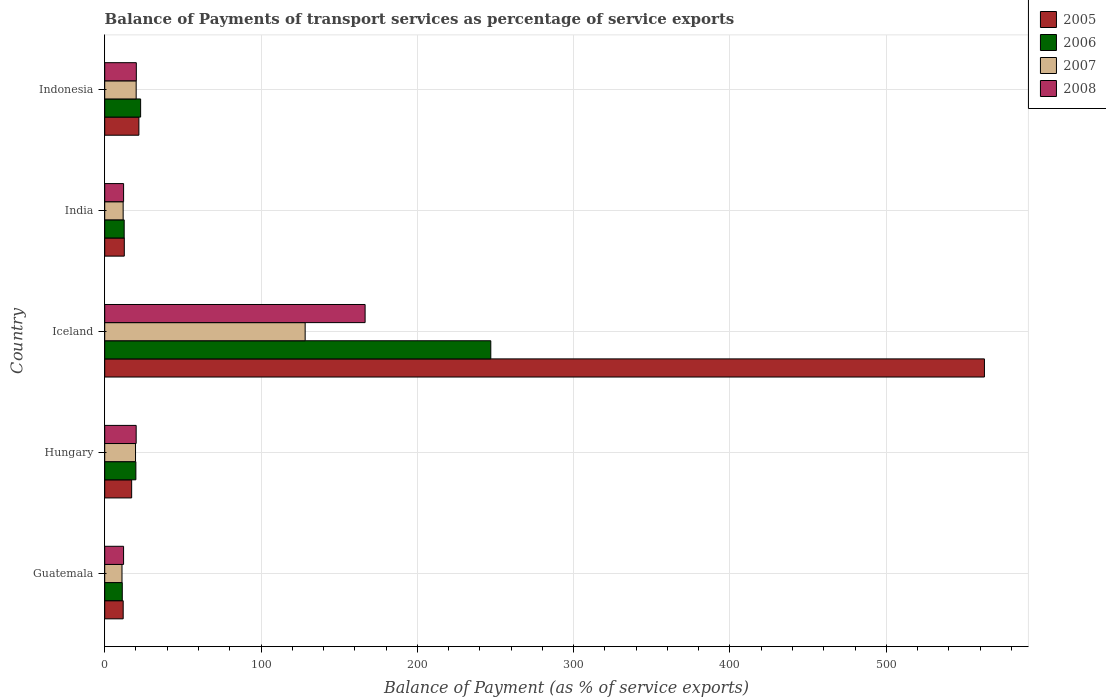How many groups of bars are there?
Give a very brief answer. 5. Are the number of bars per tick equal to the number of legend labels?
Provide a succinct answer. Yes. Are the number of bars on each tick of the Y-axis equal?
Your answer should be very brief. Yes. How many bars are there on the 4th tick from the bottom?
Your answer should be compact. 4. What is the label of the 5th group of bars from the top?
Make the answer very short. Guatemala. What is the balance of payments of transport services in 2008 in Indonesia?
Give a very brief answer. 20.22. Across all countries, what is the maximum balance of payments of transport services in 2008?
Provide a succinct answer. 166.58. Across all countries, what is the minimum balance of payments of transport services in 2006?
Your response must be concise. 11.24. In which country was the balance of payments of transport services in 2006 maximum?
Offer a terse response. Iceland. In which country was the balance of payments of transport services in 2005 minimum?
Make the answer very short. Guatemala. What is the total balance of payments of transport services in 2006 in the graph?
Your answer should be very brief. 313.6. What is the difference between the balance of payments of transport services in 2006 in India and that in Indonesia?
Give a very brief answer. -10.52. What is the difference between the balance of payments of transport services in 2006 in India and the balance of payments of transport services in 2008 in Guatemala?
Provide a short and direct response. 0.4. What is the average balance of payments of transport services in 2007 per country?
Provide a succinct answer. 38.18. What is the difference between the balance of payments of transport services in 2006 and balance of payments of transport services in 2007 in Hungary?
Keep it short and to the point. 0.22. In how many countries, is the balance of payments of transport services in 2005 greater than 300 %?
Offer a terse response. 1. What is the ratio of the balance of payments of transport services in 2006 in Guatemala to that in Indonesia?
Your response must be concise. 0.49. What is the difference between the highest and the second highest balance of payments of transport services in 2005?
Your response must be concise. 540.94. What is the difference between the highest and the lowest balance of payments of transport services in 2007?
Give a very brief answer. 117.17. In how many countries, is the balance of payments of transport services in 2007 greater than the average balance of payments of transport services in 2007 taken over all countries?
Your answer should be compact. 1. What does the 2nd bar from the bottom in Guatemala represents?
Your answer should be compact. 2006. How many bars are there?
Provide a short and direct response. 20. How many countries are there in the graph?
Offer a terse response. 5. Are the values on the major ticks of X-axis written in scientific E-notation?
Keep it short and to the point. No. Where does the legend appear in the graph?
Provide a short and direct response. Top right. How many legend labels are there?
Your answer should be compact. 4. How are the legend labels stacked?
Provide a short and direct response. Vertical. What is the title of the graph?
Offer a terse response. Balance of Payments of transport services as percentage of service exports. Does "2002" appear as one of the legend labels in the graph?
Your answer should be compact. No. What is the label or title of the X-axis?
Keep it short and to the point. Balance of Payment (as % of service exports). What is the Balance of Payment (as % of service exports) of 2005 in Guatemala?
Provide a succinct answer. 11.81. What is the Balance of Payment (as % of service exports) in 2006 in Guatemala?
Provide a short and direct response. 11.24. What is the Balance of Payment (as % of service exports) in 2007 in Guatemala?
Your answer should be very brief. 11.06. What is the Balance of Payment (as % of service exports) of 2008 in Guatemala?
Provide a short and direct response. 12.06. What is the Balance of Payment (as % of service exports) in 2005 in Hungary?
Keep it short and to the point. 17.23. What is the Balance of Payment (as % of service exports) in 2006 in Hungary?
Your answer should be very brief. 19.93. What is the Balance of Payment (as % of service exports) in 2007 in Hungary?
Ensure brevity in your answer.  19.71. What is the Balance of Payment (as % of service exports) in 2008 in Hungary?
Your answer should be very brief. 20.12. What is the Balance of Payment (as % of service exports) of 2005 in Iceland?
Your answer should be very brief. 562.81. What is the Balance of Payment (as % of service exports) of 2006 in Iceland?
Ensure brevity in your answer.  247. What is the Balance of Payment (as % of service exports) in 2007 in Iceland?
Provide a succinct answer. 128.23. What is the Balance of Payment (as % of service exports) in 2008 in Iceland?
Provide a short and direct response. 166.58. What is the Balance of Payment (as % of service exports) in 2005 in India?
Your answer should be compact. 12.53. What is the Balance of Payment (as % of service exports) of 2006 in India?
Your answer should be very brief. 12.46. What is the Balance of Payment (as % of service exports) in 2007 in India?
Give a very brief answer. 11.8. What is the Balance of Payment (as % of service exports) in 2008 in India?
Give a very brief answer. 12.07. What is the Balance of Payment (as % of service exports) in 2005 in Indonesia?
Give a very brief answer. 21.87. What is the Balance of Payment (as % of service exports) of 2006 in Indonesia?
Keep it short and to the point. 22.98. What is the Balance of Payment (as % of service exports) in 2007 in Indonesia?
Offer a terse response. 20.12. What is the Balance of Payment (as % of service exports) in 2008 in Indonesia?
Offer a terse response. 20.22. Across all countries, what is the maximum Balance of Payment (as % of service exports) of 2005?
Give a very brief answer. 562.81. Across all countries, what is the maximum Balance of Payment (as % of service exports) of 2006?
Provide a succinct answer. 247. Across all countries, what is the maximum Balance of Payment (as % of service exports) in 2007?
Your answer should be compact. 128.23. Across all countries, what is the maximum Balance of Payment (as % of service exports) of 2008?
Your answer should be very brief. 166.58. Across all countries, what is the minimum Balance of Payment (as % of service exports) of 2005?
Make the answer very short. 11.81. Across all countries, what is the minimum Balance of Payment (as % of service exports) in 2006?
Your response must be concise. 11.24. Across all countries, what is the minimum Balance of Payment (as % of service exports) in 2007?
Your answer should be very brief. 11.06. Across all countries, what is the minimum Balance of Payment (as % of service exports) of 2008?
Your answer should be very brief. 12.06. What is the total Balance of Payment (as % of service exports) in 2005 in the graph?
Keep it short and to the point. 626.25. What is the total Balance of Payment (as % of service exports) of 2006 in the graph?
Your response must be concise. 313.6. What is the total Balance of Payment (as % of service exports) of 2007 in the graph?
Ensure brevity in your answer.  190.92. What is the total Balance of Payment (as % of service exports) in 2008 in the graph?
Ensure brevity in your answer.  231.06. What is the difference between the Balance of Payment (as % of service exports) in 2005 in Guatemala and that in Hungary?
Provide a succinct answer. -5.42. What is the difference between the Balance of Payment (as % of service exports) of 2006 in Guatemala and that in Hungary?
Your answer should be very brief. -8.7. What is the difference between the Balance of Payment (as % of service exports) in 2007 in Guatemala and that in Hungary?
Ensure brevity in your answer.  -8.66. What is the difference between the Balance of Payment (as % of service exports) in 2008 in Guatemala and that in Hungary?
Your response must be concise. -8.06. What is the difference between the Balance of Payment (as % of service exports) in 2005 in Guatemala and that in Iceland?
Make the answer very short. -550.99. What is the difference between the Balance of Payment (as % of service exports) of 2006 in Guatemala and that in Iceland?
Provide a succinct answer. -235.76. What is the difference between the Balance of Payment (as % of service exports) of 2007 in Guatemala and that in Iceland?
Provide a succinct answer. -117.17. What is the difference between the Balance of Payment (as % of service exports) in 2008 in Guatemala and that in Iceland?
Your answer should be compact. -154.52. What is the difference between the Balance of Payment (as % of service exports) of 2005 in Guatemala and that in India?
Your answer should be compact. -0.71. What is the difference between the Balance of Payment (as % of service exports) in 2006 in Guatemala and that in India?
Your answer should be very brief. -1.22. What is the difference between the Balance of Payment (as % of service exports) in 2007 in Guatemala and that in India?
Your answer should be compact. -0.74. What is the difference between the Balance of Payment (as % of service exports) in 2008 in Guatemala and that in India?
Offer a very short reply. -0.01. What is the difference between the Balance of Payment (as % of service exports) in 2005 in Guatemala and that in Indonesia?
Keep it short and to the point. -10.05. What is the difference between the Balance of Payment (as % of service exports) of 2006 in Guatemala and that in Indonesia?
Ensure brevity in your answer.  -11.74. What is the difference between the Balance of Payment (as % of service exports) of 2007 in Guatemala and that in Indonesia?
Provide a short and direct response. -9.07. What is the difference between the Balance of Payment (as % of service exports) of 2008 in Guatemala and that in Indonesia?
Offer a terse response. -8.16. What is the difference between the Balance of Payment (as % of service exports) of 2005 in Hungary and that in Iceland?
Provide a short and direct response. -545.58. What is the difference between the Balance of Payment (as % of service exports) of 2006 in Hungary and that in Iceland?
Your answer should be compact. -227.06. What is the difference between the Balance of Payment (as % of service exports) in 2007 in Hungary and that in Iceland?
Keep it short and to the point. -108.51. What is the difference between the Balance of Payment (as % of service exports) in 2008 in Hungary and that in Iceland?
Provide a succinct answer. -146.46. What is the difference between the Balance of Payment (as % of service exports) of 2005 in Hungary and that in India?
Offer a very short reply. 4.7. What is the difference between the Balance of Payment (as % of service exports) in 2006 in Hungary and that in India?
Provide a short and direct response. 7.47. What is the difference between the Balance of Payment (as % of service exports) of 2007 in Hungary and that in India?
Your answer should be compact. 7.92. What is the difference between the Balance of Payment (as % of service exports) in 2008 in Hungary and that in India?
Your answer should be compact. 8.05. What is the difference between the Balance of Payment (as % of service exports) in 2005 in Hungary and that in Indonesia?
Keep it short and to the point. -4.64. What is the difference between the Balance of Payment (as % of service exports) of 2006 in Hungary and that in Indonesia?
Provide a short and direct response. -3.04. What is the difference between the Balance of Payment (as % of service exports) in 2007 in Hungary and that in Indonesia?
Give a very brief answer. -0.41. What is the difference between the Balance of Payment (as % of service exports) in 2008 in Hungary and that in Indonesia?
Your answer should be compact. -0.1. What is the difference between the Balance of Payment (as % of service exports) in 2005 in Iceland and that in India?
Your answer should be very brief. 550.28. What is the difference between the Balance of Payment (as % of service exports) of 2006 in Iceland and that in India?
Give a very brief answer. 234.54. What is the difference between the Balance of Payment (as % of service exports) in 2007 in Iceland and that in India?
Keep it short and to the point. 116.43. What is the difference between the Balance of Payment (as % of service exports) in 2008 in Iceland and that in India?
Provide a short and direct response. 154.51. What is the difference between the Balance of Payment (as % of service exports) in 2005 in Iceland and that in Indonesia?
Ensure brevity in your answer.  540.94. What is the difference between the Balance of Payment (as % of service exports) in 2006 in Iceland and that in Indonesia?
Give a very brief answer. 224.02. What is the difference between the Balance of Payment (as % of service exports) in 2007 in Iceland and that in Indonesia?
Your answer should be very brief. 108.1. What is the difference between the Balance of Payment (as % of service exports) in 2008 in Iceland and that in Indonesia?
Provide a short and direct response. 146.36. What is the difference between the Balance of Payment (as % of service exports) in 2005 in India and that in Indonesia?
Your answer should be very brief. -9.34. What is the difference between the Balance of Payment (as % of service exports) in 2006 in India and that in Indonesia?
Provide a short and direct response. -10.52. What is the difference between the Balance of Payment (as % of service exports) of 2007 in India and that in Indonesia?
Offer a very short reply. -8.33. What is the difference between the Balance of Payment (as % of service exports) in 2008 in India and that in Indonesia?
Give a very brief answer. -8.15. What is the difference between the Balance of Payment (as % of service exports) in 2005 in Guatemala and the Balance of Payment (as % of service exports) in 2006 in Hungary?
Provide a short and direct response. -8.12. What is the difference between the Balance of Payment (as % of service exports) of 2005 in Guatemala and the Balance of Payment (as % of service exports) of 2007 in Hungary?
Provide a succinct answer. -7.9. What is the difference between the Balance of Payment (as % of service exports) of 2005 in Guatemala and the Balance of Payment (as % of service exports) of 2008 in Hungary?
Offer a terse response. -8.31. What is the difference between the Balance of Payment (as % of service exports) of 2006 in Guatemala and the Balance of Payment (as % of service exports) of 2007 in Hungary?
Give a very brief answer. -8.47. What is the difference between the Balance of Payment (as % of service exports) of 2006 in Guatemala and the Balance of Payment (as % of service exports) of 2008 in Hungary?
Provide a short and direct response. -8.88. What is the difference between the Balance of Payment (as % of service exports) of 2007 in Guatemala and the Balance of Payment (as % of service exports) of 2008 in Hungary?
Make the answer very short. -9.06. What is the difference between the Balance of Payment (as % of service exports) in 2005 in Guatemala and the Balance of Payment (as % of service exports) in 2006 in Iceland?
Your answer should be very brief. -235.18. What is the difference between the Balance of Payment (as % of service exports) of 2005 in Guatemala and the Balance of Payment (as % of service exports) of 2007 in Iceland?
Ensure brevity in your answer.  -116.41. What is the difference between the Balance of Payment (as % of service exports) in 2005 in Guatemala and the Balance of Payment (as % of service exports) in 2008 in Iceland?
Make the answer very short. -154.77. What is the difference between the Balance of Payment (as % of service exports) of 2006 in Guatemala and the Balance of Payment (as % of service exports) of 2007 in Iceland?
Offer a very short reply. -116.99. What is the difference between the Balance of Payment (as % of service exports) of 2006 in Guatemala and the Balance of Payment (as % of service exports) of 2008 in Iceland?
Give a very brief answer. -155.34. What is the difference between the Balance of Payment (as % of service exports) of 2007 in Guatemala and the Balance of Payment (as % of service exports) of 2008 in Iceland?
Give a very brief answer. -155.53. What is the difference between the Balance of Payment (as % of service exports) of 2005 in Guatemala and the Balance of Payment (as % of service exports) of 2006 in India?
Offer a terse response. -0.65. What is the difference between the Balance of Payment (as % of service exports) in 2005 in Guatemala and the Balance of Payment (as % of service exports) in 2007 in India?
Your answer should be very brief. 0.02. What is the difference between the Balance of Payment (as % of service exports) of 2005 in Guatemala and the Balance of Payment (as % of service exports) of 2008 in India?
Provide a succinct answer. -0.26. What is the difference between the Balance of Payment (as % of service exports) of 2006 in Guatemala and the Balance of Payment (as % of service exports) of 2007 in India?
Provide a short and direct response. -0.56. What is the difference between the Balance of Payment (as % of service exports) in 2006 in Guatemala and the Balance of Payment (as % of service exports) in 2008 in India?
Offer a very short reply. -0.83. What is the difference between the Balance of Payment (as % of service exports) of 2007 in Guatemala and the Balance of Payment (as % of service exports) of 2008 in India?
Provide a succinct answer. -1.02. What is the difference between the Balance of Payment (as % of service exports) in 2005 in Guatemala and the Balance of Payment (as % of service exports) in 2006 in Indonesia?
Keep it short and to the point. -11.16. What is the difference between the Balance of Payment (as % of service exports) of 2005 in Guatemala and the Balance of Payment (as % of service exports) of 2007 in Indonesia?
Give a very brief answer. -8.31. What is the difference between the Balance of Payment (as % of service exports) of 2005 in Guatemala and the Balance of Payment (as % of service exports) of 2008 in Indonesia?
Provide a short and direct response. -8.41. What is the difference between the Balance of Payment (as % of service exports) of 2006 in Guatemala and the Balance of Payment (as % of service exports) of 2007 in Indonesia?
Offer a terse response. -8.89. What is the difference between the Balance of Payment (as % of service exports) of 2006 in Guatemala and the Balance of Payment (as % of service exports) of 2008 in Indonesia?
Your answer should be very brief. -8.99. What is the difference between the Balance of Payment (as % of service exports) of 2007 in Guatemala and the Balance of Payment (as % of service exports) of 2008 in Indonesia?
Provide a succinct answer. -9.17. What is the difference between the Balance of Payment (as % of service exports) of 2005 in Hungary and the Balance of Payment (as % of service exports) of 2006 in Iceland?
Give a very brief answer. -229.77. What is the difference between the Balance of Payment (as % of service exports) in 2005 in Hungary and the Balance of Payment (as % of service exports) in 2007 in Iceland?
Your answer should be compact. -111. What is the difference between the Balance of Payment (as % of service exports) of 2005 in Hungary and the Balance of Payment (as % of service exports) of 2008 in Iceland?
Provide a succinct answer. -149.35. What is the difference between the Balance of Payment (as % of service exports) of 2006 in Hungary and the Balance of Payment (as % of service exports) of 2007 in Iceland?
Offer a very short reply. -108.29. What is the difference between the Balance of Payment (as % of service exports) in 2006 in Hungary and the Balance of Payment (as % of service exports) in 2008 in Iceland?
Make the answer very short. -146.65. What is the difference between the Balance of Payment (as % of service exports) of 2007 in Hungary and the Balance of Payment (as % of service exports) of 2008 in Iceland?
Keep it short and to the point. -146.87. What is the difference between the Balance of Payment (as % of service exports) of 2005 in Hungary and the Balance of Payment (as % of service exports) of 2006 in India?
Ensure brevity in your answer.  4.77. What is the difference between the Balance of Payment (as % of service exports) in 2005 in Hungary and the Balance of Payment (as % of service exports) in 2007 in India?
Provide a short and direct response. 5.43. What is the difference between the Balance of Payment (as % of service exports) in 2005 in Hungary and the Balance of Payment (as % of service exports) in 2008 in India?
Your response must be concise. 5.16. What is the difference between the Balance of Payment (as % of service exports) in 2006 in Hungary and the Balance of Payment (as % of service exports) in 2007 in India?
Offer a very short reply. 8.14. What is the difference between the Balance of Payment (as % of service exports) of 2006 in Hungary and the Balance of Payment (as % of service exports) of 2008 in India?
Make the answer very short. 7.86. What is the difference between the Balance of Payment (as % of service exports) in 2007 in Hungary and the Balance of Payment (as % of service exports) in 2008 in India?
Offer a terse response. 7.64. What is the difference between the Balance of Payment (as % of service exports) of 2005 in Hungary and the Balance of Payment (as % of service exports) of 2006 in Indonesia?
Your response must be concise. -5.75. What is the difference between the Balance of Payment (as % of service exports) of 2005 in Hungary and the Balance of Payment (as % of service exports) of 2007 in Indonesia?
Provide a succinct answer. -2.89. What is the difference between the Balance of Payment (as % of service exports) of 2005 in Hungary and the Balance of Payment (as % of service exports) of 2008 in Indonesia?
Your answer should be compact. -2.99. What is the difference between the Balance of Payment (as % of service exports) in 2006 in Hungary and the Balance of Payment (as % of service exports) in 2007 in Indonesia?
Offer a terse response. -0.19. What is the difference between the Balance of Payment (as % of service exports) in 2006 in Hungary and the Balance of Payment (as % of service exports) in 2008 in Indonesia?
Your response must be concise. -0.29. What is the difference between the Balance of Payment (as % of service exports) of 2007 in Hungary and the Balance of Payment (as % of service exports) of 2008 in Indonesia?
Make the answer very short. -0.51. What is the difference between the Balance of Payment (as % of service exports) in 2005 in Iceland and the Balance of Payment (as % of service exports) in 2006 in India?
Your response must be concise. 550.35. What is the difference between the Balance of Payment (as % of service exports) in 2005 in Iceland and the Balance of Payment (as % of service exports) in 2007 in India?
Your response must be concise. 551.01. What is the difference between the Balance of Payment (as % of service exports) of 2005 in Iceland and the Balance of Payment (as % of service exports) of 2008 in India?
Offer a terse response. 550.73. What is the difference between the Balance of Payment (as % of service exports) in 2006 in Iceland and the Balance of Payment (as % of service exports) in 2007 in India?
Make the answer very short. 235.2. What is the difference between the Balance of Payment (as % of service exports) in 2006 in Iceland and the Balance of Payment (as % of service exports) in 2008 in India?
Offer a very short reply. 234.92. What is the difference between the Balance of Payment (as % of service exports) in 2007 in Iceland and the Balance of Payment (as % of service exports) in 2008 in India?
Your answer should be compact. 116.15. What is the difference between the Balance of Payment (as % of service exports) of 2005 in Iceland and the Balance of Payment (as % of service exports) of 2006 in Indonesia?
Offer a very short reply. 539.83. What is the difference between the Balance of Payment (as % of service exports) of 2005 in Iceland and the Balance of Payment (as % of service exports) of 2007 in Indonesia?
Provide a succinct answer. 542.68. What is the difference between the Balance of Payment (as % of service exports) of 2005 in Iceland and the Balance of Payment (as % of service exports) of 2008 in Indonesia?
Your answer should be compact. 542.58. What is the difference between the Balance of Payment (as % of service exports) of 2006 in Iceland and the Balance of Payment (as % of service exports) of 2007 in Indonesia?
Make the answer very short. 226.87. What is the difference between the Balance of Payment (as % of service exports) in 2006 in Iceland and the Balance of Payment (as % of service exports) in 2008 in Indonesia?
Your answer should be compact. 226.77. What is the difference between the Balance of Payment (as % of service exports) of 2007 in Iceland and the Balance of Payment (as % of service exports) of 2008 in Indonesia?
Keep it short and to the point. 108. What is the difference between the Balance of Payment (as % of service exports) in 2005 in India and the Balance of Payment (as % of service exports) in 2006 in Indonesia?
Keep it short and to the point. -10.45. What is the difference between the Balance of Payment (as % of service exports) of 2005 in India and the Balance of Payment (as % of service exports) of 2007 in Indonesia?
Provide a succinct answer. -7.6. What is the difference between the Balance of Payment (as % of service exports) in 2005 in India and the Balance of Payment (as % of service exports) in 2008 in Indonesia?
Offer a terse response. -7.7. What is the difference between the Balance of Payment (as % of service exports) of 2006 in India and the Balance of Payment (as % of service exports) of 2007 in Indonesia?
Ensure brevity in your answer.  -7.66. What is the difference between the Balance of Payment (as % of service exports) of 2006 in India and the Balance of Payment (as % of service exports) of 2008 in Indonesia?
Ensure brevity in your answer.  -7.77. What is the difference between the Balance of Payment (as % of service exports) of 2007 in India and the Balance of Payment (as % of service exports) of 2008 in Indonesia?
Give a very brief answer. -8.43. What is the average Balance of Payment (as % of service exports) in 2005 per country?
Ensure brevity in your answer.  125.25. What is the average Balance of Payment (as % of service exports) of 2006 per country?
Offer a very short reply. 62.72. What is the average Balance of Payment (as % of service exports) of 2007 per country?
Provide a succinct answer. 38.18. What is the average Balance of Payment (as % of service exports) of 2008 per country?
Offer a terse response. 46.21. What is the difference between the Balance of Payment (as % of service exports) of 2005 and Balance of Payment (as % of service exports) of 2006 in Guatemala?
Provide a short and direct response. 0.58. What is the difference between the Balance of Payment (as % of service exports) in 2005 and Balance of Payment (as % of service exports) in 2007 in Guatemala?
Provide a short and direct response. 0.76. What is the difference between the Balance of Payment (as % of service exports) of 2005 and Balance of Payment (as % of service exports) of 2008 in Guatemala?
Make the answer very short. -0.25. What is the difference between the Balance of Payment (as % of service exports) in 2006 and Balance of Payment (as % of service exports) in 2007 in Guatemala?
Make the answer very short. 0.18. What is the difference between the Balance of Payment (as % of service exports) of 2006 and Balance of Payment (as % of service exports) of 2008 in Guatemala?
Offer a very short reply. -0.82. What is the difference between the Balance of Payment (as % of service exports) of 2007 and Balance of Payment (as % of service exports) of 2008 in Guatemala?
Keep it short and to the point. -1.01. What is the difference between the Balance of Payment (as % of service exports) in 2005 and Balance of Payment (as % of service exports) in 2006 in Hungary?
Ensure brevity in your answer.  -2.7. What is the difference between the Balance of Payment (as % of service exports) of 2005 and Balance of Payment (as % of service exports) of 2007 in Hungary?
Provide a short and direct response. -2.48. What is the difference between the Balance of Payment (as % of service exports) of 2005 and Balance of Payment (as % of service exports) of 2008 in Hungary?
Keep it short and to the point. -2.89. What is the difference between the Balance of Payment (as % of service exports) in 2006 and Balance of Payment (as % of service exports) in 2007 in Hungary?
Provide a short and direct response. 0.22. What is the difference between the Balance of Payment (as % of service exports) of 2006 and Balance of Payment (as % of service exports) of 2008 in Hungary?
Keep it short and to the point. -0.19. What is the difference between the Balance of Payment (as % of service exports) of 2007 and Balance of Payment (as % of service exports) of 2008 in Hungary?
Your response must be concise. -0.41. What is the difference between the Balance of Payment (as % of service exports) in 2005 and Balance of Payment (as % of service exports) in 2006 in Iceland?
Provide a succinct answer. 315.81. What is the difference between the Balance of Payment (as % of service exports) in 2005 and Balance of Payment (as % of service exports) in 2007 in Iceland?
Offer a very short reply. 434.58. What is the difference between the Balance of Payment (as % of service exports) in 2005 and Balance of Payment (as % of service exports) in 2008 in Iceland?
Give a very brief answer. 396.23. What is the difference between the Balance of Payment (as % of service exports) in 2006 and Balance of Payment (as % of service exports) in 2007 in Iceland?
Ensure brevity in your answer.  118.77. What is the difference between the Balance of Payment (as % of service exports) of 2006 and Balance of Payment (as % of service exports) of 2008 in Iceland?
Provide a short and direct response. 80.42. What is the difference between the Balance of Payment (as % of service exports) in 2007 and Balance of Payment (as % of service exports) in 2008 in Iceland?
Offer a very short reply. -38.35. What is the difference between the Balance of Payment (as % of service exports) in 2005 and Balance of Payment (as % of service exports) in 2006 in India?
Give a very brief answer. 0.07. What is the difference between the Balance of Payment (as % of service exports) in 2005 and Balance of Payment (as % of service exports) in 2007 in India?
Keep it short and to the point. 0.73. What is the difference between the Balance of Payment (as % of service exports) in 2005 and Balance of Payment (as % of service exports) in 2008 in India?
Ensure brevity in your answer.  0.45. What is the difference between the Balance of Payment (as % of service exports) of 2006 and Balance of Payment (as % of service exports) of 2007 in India?
Your answer should be compact. 0.66. What is the difference between the Balance of Payment (as % of service exports) of 2006 and Balance of Payment (as % of service exports) of 2008 in India?
Your response must be concise. 0.39. What is the difference between the Balance of Payment (as % of service exports) of 2007 and Balance of Payment (as % of service exports) of 2008 in India?
Ensure brevity in your answer.  -0.28. What is the difference between the Balance of Payment (as % of service exports) of 2005 and Balance of Payment (as % of service exports) of 2006 in Indonesia?
Your answer should be compact. -1.11. What is the difference between the Balance of Payment (as % of service exports) in 2005 and Balance of Payment (as % of service exports) in 2007 in Indonesia?
Your answer should be very brief. 1.74. What is the difference between the Balance of Payment (as % of service exports) of 2005 and Balance of Payment (as % of service exports) of 2008 in Indonesia?
Offer a terse response. 1.64. What is the difference between the Balance of Payment (as % of service exports) of 2006 and Balance of Payment (as % of service exports) of 2007 in Indonesia?
Make the answer very short. 2.85. What is the difference between the Balance of Payment (as % of service exports) of 2006 and Balance of Payment (as % of service exports) of 2008 in Indonesia?
Provide a short and direct response. 2.75. What is the difference between the Balance of Payment (as % of service exports) in 2007 and Balance of Payment (as % of service exports) in 2008 in Indonesia?
Your answer should be very brief. -0.1. What is the ratio of the Balance of Payment (as % of service exports) of 2005 in Guatemala to that in Hungary?
Your answer should be very brief. 0.69. What is the ratio of the Balance of Payment (as % of service exports) of 2006 in Guatemala to that in Hungary?
Provide a succinct answer. 0.56. What is the ratio of the Balance of Payment (as % of service exports) of 2007 in Guatemala to that in Hungary?
Your answer should be compact. 0.56. What is the ratio of the Balance of Payment (as % of service exports) of 2008 in Guatemala to that in Hungary?
Provide a short and direct response. 0.6. What is the ratio of the Balance of Payment (as % of service exports) in 2005 in Guatemala to that in Iceland?
Give a very brief answer. 0.02. What is the ratio of the Balance of Payment (as % of service exports) in 2006 in Guatemala to that in Iceland?
Provide a succinct answer. 0.05. What is the ratio of the Balance of Payment (as % of service exports) of 2007 in Guatemala to that in Iceland?
Give a very brief answer. 0.09. What is the ratio of the Balance of Payment (as % of service exports) of 2008 in Guatemala to that in Iceland?
Your answer should be very brief. 0.07. What is the ratio of the Balance of Payment (as % of service exports) in 2005 in Guatemala to that in India?
Make the answer very short. 0.94. What is the ratio of the Balance of Payment (as % of service exports) of 2006 in Guatemala to that in India?
Offer a terse response. 0.9. What is the ratio of the Balance of Payment (as % of service exports) of 2007 in Guatemala to that in India?
Keep it short and to the point. 0.94. What is the ratio of the Balance of Payment (as % of service exports) in 2005 in Guatemala to that in Indonesia?
Your answer should be compact. 0.54. What is the ratio of the Balance of Payment (as % of service exports) in 2006 in Guatemala to that in Indonesia?
Ensure brevity in your answer.  0.49. What is the ratio of the Balance of Payment (as % of service exports) of 2007 in Guatemala to that in Indonesia?
Your answer should be compact. 0.55. What is the ratio of the Balance of Payment (as % of service exports) in 2008 in Guatemala to that in Indonesia?
Offer a very short reply. 0.6. What is the ratio of the Balance of Payment (as % of service exports) of 2005 in Hungary to that in Iceland?
Keep it short and to the point. 0.03. What is the ratio of the Balance of Payment (as % of service exports) in 2006 in Hungary to that in Iceland?
Your answer should be compact. 0.08. What is the ratio of the Balance of Payment (as % of service exports) in 2007 in Hungary to that in Iceland?
Offer a very short reply. 0.15. What is the ratio of the Balance of Payment (as % of service exports) in 2008 in Hungary to that in Iceland?
Give a very brief answer. 0.12. What is the ratio of the Balance of Payment (as % of service exports) in 2005 in Hungary to that in India?
Provide a succinct answer. 1.38. What is the ratio of the Balance of Payment (as % of service exports) of 2006 in Hungary to that in India?
Offer a very short reply. 1.6. What is the ratio of the Balance of Payment (as % of service exports) in 2007 in Hungary to that in India?
Offer a terse response. 1.67. What is the ratio of the Balance of Payment (as % of service exports) of 2008 in Hungary to that in India?
Your answer should be compact. 1.67. What is the ratio of the Balance of Payment (as % of service exports) of 2005 in Hungary to that in Indonesia?
Your answer should be compact. 0.79. What is the ratio of the Balance of Payment (as % of service exports) of 2006 in Hungary to that in Indonesia?
Your response must be concise. 0.87. What is the ratio of the Balance of Payment (as % of service exports) in 2007 in Hungary to that in Indonesia?
Give a very brief answer. 0.98. What is the ratio of the Balance of Payment (as % of service exports) in 2008 in Hungary to that in Indonesia?
Give a very brief answer. 0.99. What is the ratio of the Balance of Payment (as % of service exports) of 2005 in Iceland to that in India?
Provide a short and direct response. 44.92. What is the ratio of the Balance of Payment (as % of service exports) in 2006 in Iceland to that in India?
Offer a very short reply. 19.82. What is the ratio of the Balance of Payment (as % of service exports) of 2007 in Iceland to that in India?
Your response must be concise. 10.87. What is the ratio of the Balance of Payment (as % of service exports) in 2008 in Iceland to that in India?
Your answer should be compact. 13.8. What is the ratio of the Balance of Payment (as % of service exports) of 2005 in Iceland to that in Indonesia?
Provide a succinct answer. 25.74. What is the ratio of the Balance of Payment (as % of service exports) in 2006 in Iceland to that in Indonesia?
Offer a terse response. 10.75. What is the ratio of the Balance of Payment (as % of service exports) of 2007 in Iceland to that in Indonesia?
Your answer should be compact. 6.37. What is the ratio of the Balance of Payment (as % of service exports) in 2008 in Iceland to that in Indonesia?
Your response must be concise. 8.24. What is the ratio of the Balance of Payment (as % of service exports) of 2005 in India to that in Indonesia?
Your answer should be very brief. 0.57. What is the ratio of the Balance of Payment (as % of service exports) of 2006 in India to that in Indonesia?
Offer a terse response. 0.54. What is the ratio of the Balance of Payment (as % of service exports) in 2007 in India to that in Indonesia?
Give a very brief answer. 0.59. What is the ratio of the Balance of Payment (as % of service exports) in 2008 in India to that in Indonesia?
Give a very brief answer. 0.6. What is the difference between the highest and the second highest Balance of Payment (as % of service exports) of 2005?
Ensure brevity in your answer.  540.94. What is the difference between the highest and the second highest Balance of Payment (as % of service exports) in 2006?
Your answer should be very brief. 224.02. What is the difference between the highest and the second highest Balance of Payment (as % of service exports) in 2007?
Your answer should be very brief. 108.1. What is the difference between the highest and the second highest Balance of Payment (as % of service exports) of 2008?
Keep it short and to the point. 146.36. What is the difference between the highest and the lowest Balance of Payment (as % of service exports) of 2005?
Your answer should be very brief. 550.99. What is the difference between the highest and the lowest Balance of Payment (as % of service exports) of 2006?
Provide a succinct answer. 235.76. What is the difference between the highest and the lowest Balance of Payment (as % of service exports) in 2007?
Your answer should be compact. 117.17. What is the difference between the highest and the lowest Balance of Payment (as % of service exports) in 2008?
Offer a very short reply. 154.52. 